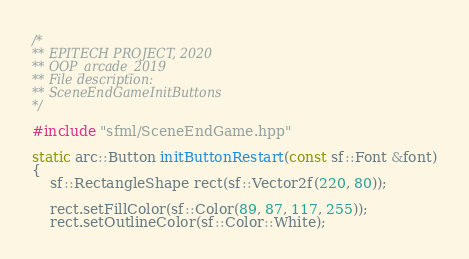<code> <loc_0><loc_0><loc_500><loc_500><_C++_>/*
** EPITECH PROJECT, 2020
** OOP_arcade_2019
** File description:
** SceneEndGameInitButtons
*/

#include "sfml/SceneEndGame.hpp"

static arc::Button initButtonRestart(const sf::Font &font)
{
    sf::RectangleShape rect(sf::Vector2f(220, 80));

    rect.setFillColor(sf::Color(89, 87, 117, 255));
    rect.setOutlineColor(sf::Color::White);</code> 